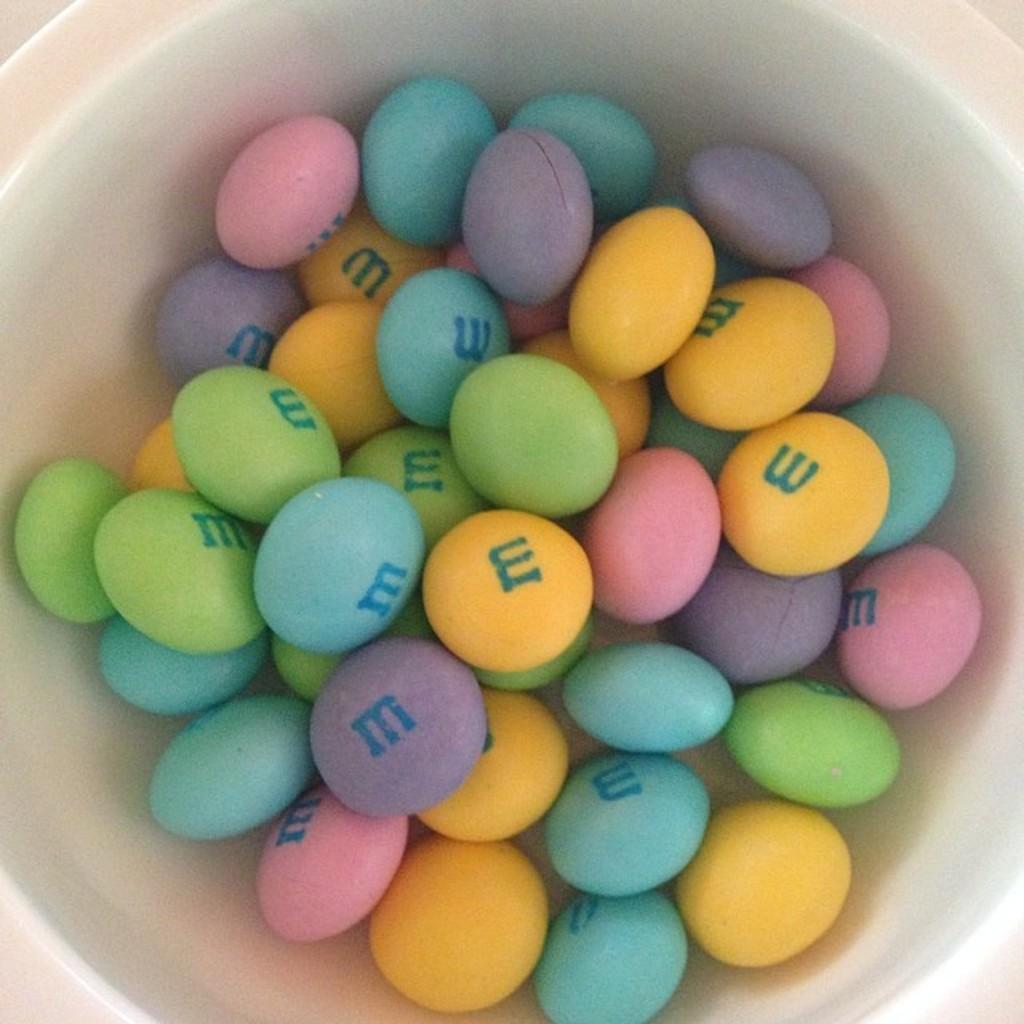Describe this image in one or two sentences. In this image I can see a white colored bowl and in the bowl I can see few m&ms which are blue, green, yellow, pink and violet in color. 